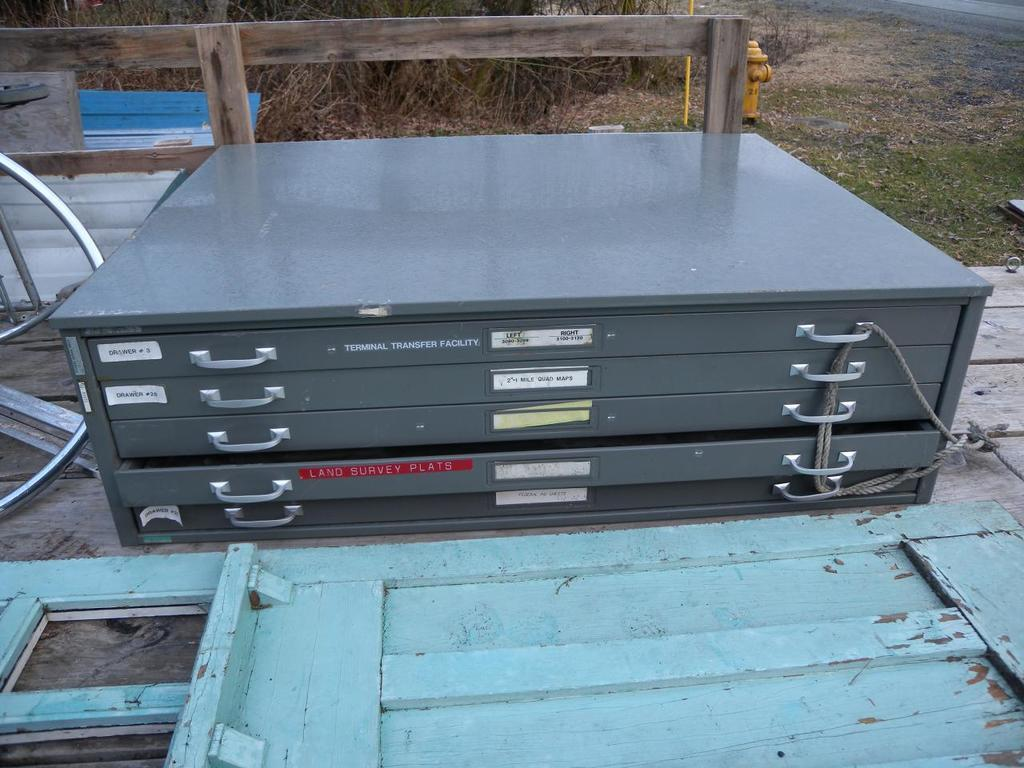<image>
Render a clear and concise summary of the photo. A file cabinet's top drawer is labelled left and right. 